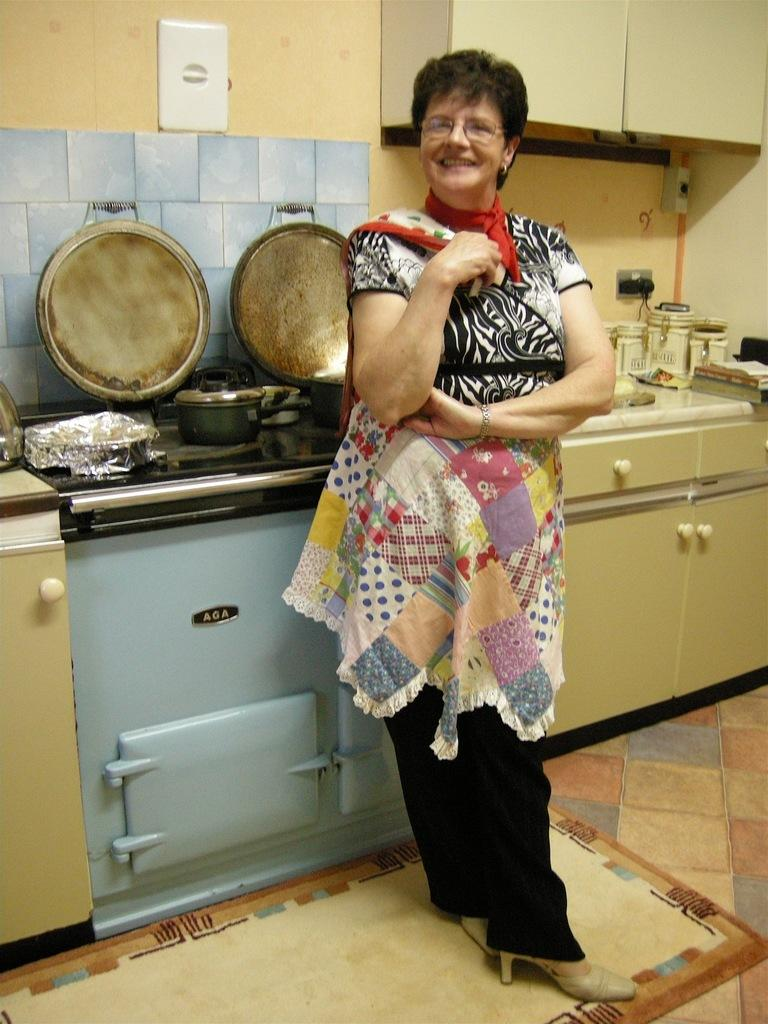<image>
Offer a succinct explanation of the picture presented. A woman standing next to an AGA brand oven. 